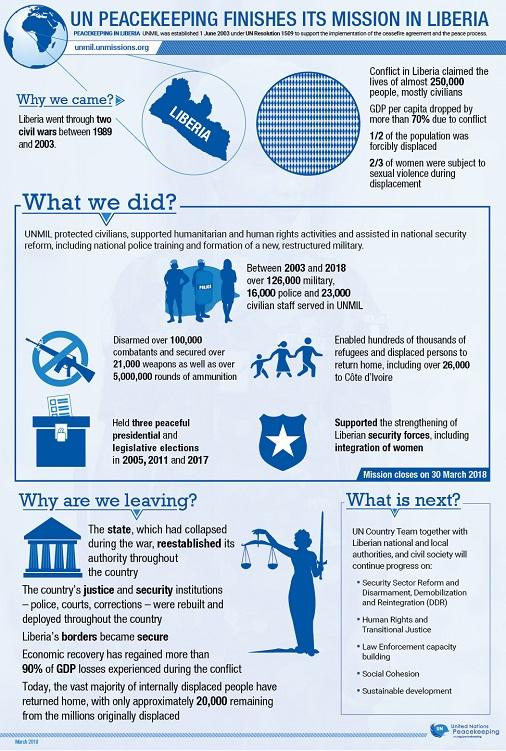Identify some key points in this picture. During the period of 1989 to 2003, there were two civil wars in Liberia. The UNMIL peacekeeping mission deployed over 126,000 military troops. In Liberia, elections were conducted with the support of the United Nations Mission in Liberia (UNMIL) during the years 2005, 2007, and 2017. According to the UNMIL peacekeeping mission, a total of 16,000 police personnel were deployed. The percentage decrease in GDP per capita due to conflict in Liberia was greater than 70%. 